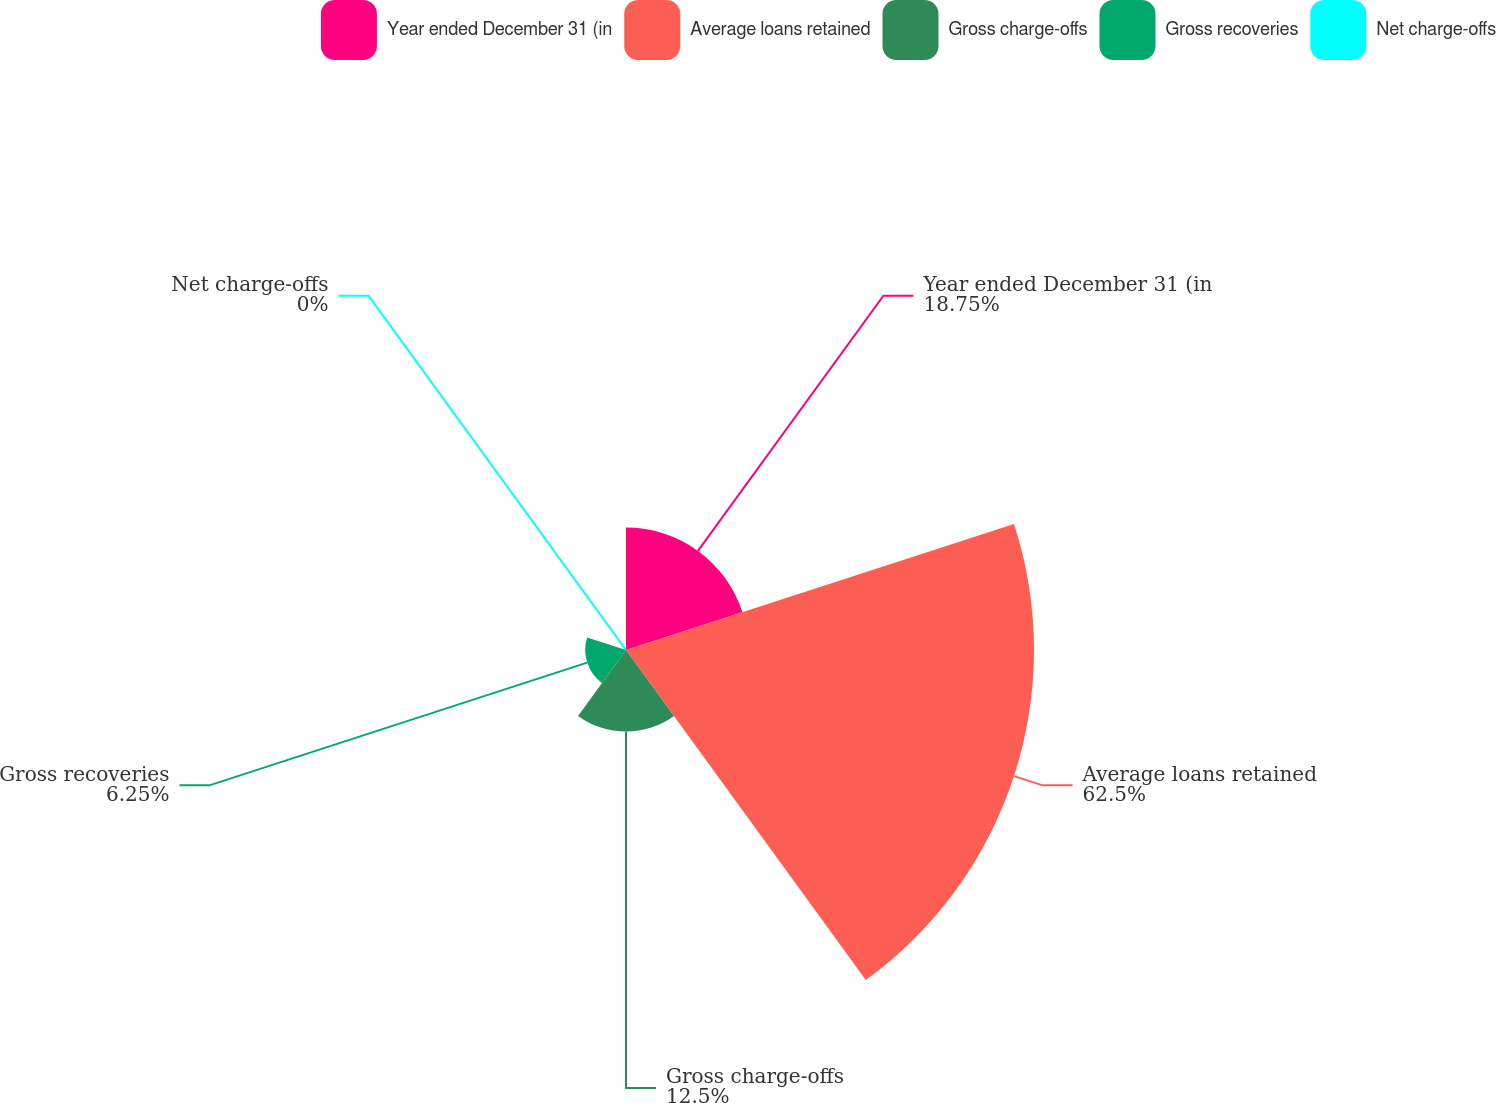Convert chart to OTSL. <chart><loc_0><loc_0><loc_500><loc_500><pie_chart><fcel>Year ended December 31 (in<fcel>Average loans retained<fcel>Gross charge-offs<fcel>Gross recoveries<fcel>Net charge-offs<nl><fcel>18.75%<fcel>62.49%<fcel>12.5%<fcel>6.25%<fcel>0.0%<nl></chart> 